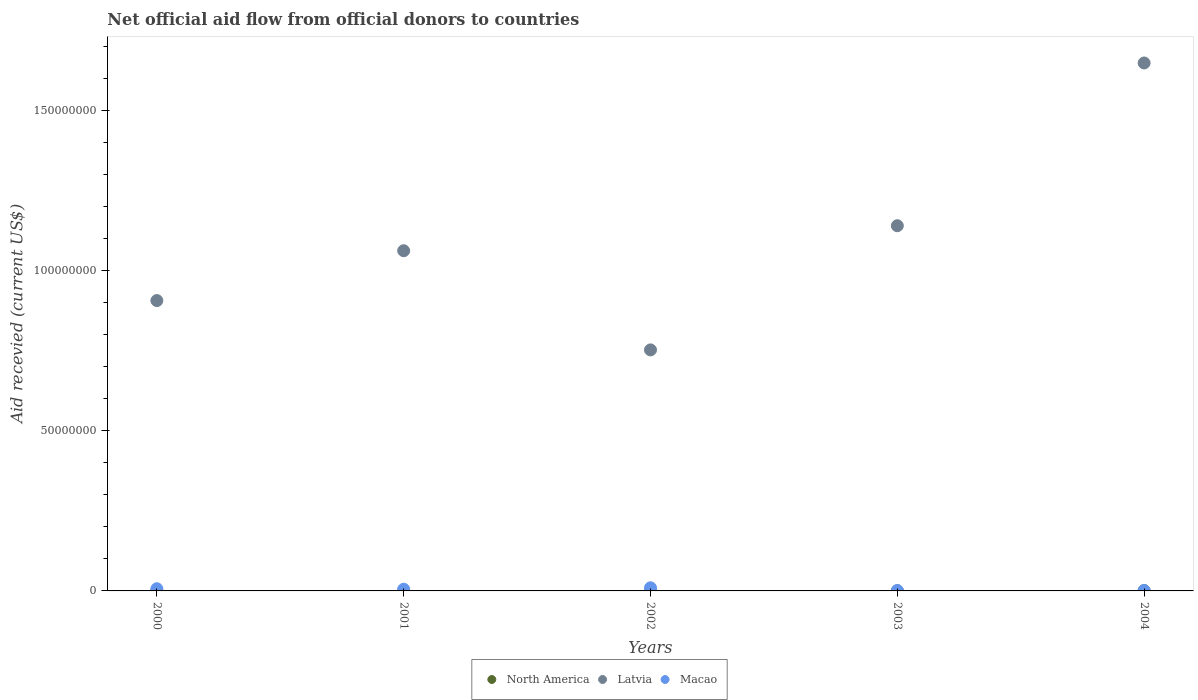How many different coloured dotlines are there?
Make the answer very short. 3. Is the number of dotlines equal to the number of legend labels?
Keep it short and to the point. Yes. Across all years, what is the maximum total aid received in Latvia?
Make the answer very short. 1.65e+08. In which year was the total aid received in North America minimum?
Keep it short and to the point. 2001. What is the total total aid received in Macao in the graph?
Make the answer very short. 2.44e+06. What is the average total aid received in North America per year?
Give a very brief answer. 4.40e+04. In the year 2003, what is the difference between the total aid received in Macao and total aid received in Latvia?
Your answer should be very brief. -1.14e+08. Is the total aid received in North America in 2001 less than that in 2004?
Your answer should be compact. Yes. What is the difference between the highest and the lowest total aid received in Macao?
Offer a very short reply. 8.60e+05. Is the sum of the total aid received in North America in 2000 and 2002 greater than the maximum total aid received in Latvia across all years?
Your response must be concise. No. Is it the case that in every year, the sum of the total aid received in Macao and total aid received in Latvia  is greater than the total aid received in North America?
Provide a short and direct response. Yes. Does the total aid received in Macao monotonically increase over the years?
Keep it short and to the point. No. Is the total aid received in Macao strictly less than the total aid received in North America over the years?
Keep it short and to the point. No. How many years are there in the graph?
Your answer should be compact. 5. What is the difference between two consecutive major ticks on the Y-axis?
Offer a terse response. 5.00e+07. Are the values on the major ticks of Y-axis written in scientific E-notation?
Make the answer very short. No. Does the graph contain any zero values?
Your answer should be compact. No. Does the graph contain grids?
Offer a very short reply. No. How are the legend labels stacked?
Make the answer very short. Horizontal. What is the title of the graph?
Ensure brevity in your answer.  Net official aid flow from official donors to countries. What is the label or title of the X-axis?
Provide a succinct answer. Years. What is the label or title of the Y-axis?
Keep it short and to the point. Aid recevied (current US$). What is the Aid recevied (current US$) of Latvia in 2000?
Ensure brevity in your answer.  9.06e+07. What is the Aid recevied (current US$) of Macao in 2000?
Give a very brief answer. 6.80e+05. What is the Aid recevied (current US$) of Latvia in 2001?
Offer a terse response. 1.06e+08. What is the Aid recevied (current US$) of Macao in 2001?
Provide a succinct answer. 5.30e+05. What is the Aid recevied (current US$) of North America in 2002?
Give a very brief answer. 2.00e+04. What is the Aid recevied (current US$) of Latvia in 2002?
Your answer should be very brief. 7.52e+07. What is the Aid recevied (current US$) of Macao in 2002?
Your answer should be very brief. 9.80e+05. What is the Aid recevied (current US$) in North America in 2003?
Provide a succinct answer. 3.00e+04. What is the Aid recevied (current US$) of Latvia in 2003?
Offer a very short reply. 1.14e+08. What is the Aid recevied (current US$) of Macao in 2003?
Provide a short and direct response. 1.30e+05. What is the Aid recevied (current US$) in Latvia in 2004?
Provide a succinct answer. 1.65e+08. What is the Aid recevied (current US$) in Macao in 2004?
Keep it short and to the point. 1.20e+05. Across all years, what is the maximum Aid recevied (current US$) in Latvia?
Provide a succinct answer. 1.65e+08. Across all years, what is the maximum Aid recevied (current US$) in Macao?
Your response must be concise. 9.80e+05. Across all years, what is the minimum Aid recevied (current US$) of North America?
Your response must be concise. 2.00e+04. Across all years, what is the minimum Aid recevied (current US$) in Latvia?
Your response must be concise. 7.52e+07. Across all years, what is the minimum Aid recevied (current US$) of Macao?
Provide a succinct answer. 1.20e+05. What is the total Aid recevied (current US$) of North America in the graph?
Your answer should be compact. 2.20e+05. What is the total Aid recevied (current US$) in Latvia in the graph?
Your response must be concise. 5.51e+08. What is the total Aid recevied (current US$) of Macao in the graph?
Offer a very short reply. 2.44e+06. What is the difference between the Aid recevied (current US$) of Latvia in 2000 and that in 2001?
Ensure brevity in your answer.  -1.56e+07. What is the difference between the Aid recevied (current US$) in Macao in 2000 and that in 2001?
Give a very brief answer. 1.50e+05. What is the difference between the Aid recevied (current US$) of North America in 2000 and that in 2002?
Ensure brevity in your answer.  4.00e+04. What is the difference between the Aid recevied (current US$) in Latvia in 2000 and that in 2002?
Your response must be concise. 1.54e+07. What is the difference between the Aid recevied (current US$) of Latvia in 2000 and that in 2003?
Provide a succinct answer. -2.34e+07. What is the difference between the Aid recevied (current US$) of Macao in 2000 and that in 2003?
Your answer should be very brief. 5.50e+05. What is the difference between the Aid recevied (current US$) in North America in 2000 and that in 2004?
Provide a succinct answer. -3.00e+04. What is the difference between the Aid recevied (current US$) in Latvia in 2000 and that in 2004?
Provide a succinct answer. -7.41e+07. What is the difference between the Aid recevied (current US$) of Macao in 2000 and that in 2004?
Offer a terse response. 5.60e+05. What is the difference between the Aid recevied (current US$) of North America in 2001 and that in 2002?
Your answer should be compact. 0. What is the difference between the Aid recevied (current US$) in Latvia in 2001 and that in 2002?
Make the answer very short. 3.09e+07. What is the difference between the Aid recevied (current US$) of Macao in 2001 and that in 2002?
Your response must be concise. -4.50e+05. What is the difference between the Aid recevied (current US$) of Latvia in 2001 and that in 2003?
Your answer should be very brief. -7.80e+06. What is the difference between the Aid recevied (current US$) of North America in 2001 and that in 2004?
Offer a very short reply. -7.00e+04. What is the difference between the Aid recevied (current US$) of Latvia in 2001 and that in 2004?
Provide a short and direct response. -5.86e+07. What is the difference between the Aid recevied (current US$) in Macao in 2001 and that in 2004?
Keep it short and to the point. 4.10e+05. What is the difference between the Aid recevied (current US$) of Latvia in 2002 and that in 2003?
Make the answer very short. -3.87e+07. What is the difference between the Aid recevied (current US$) of Macao in 2002 and that in 2003?
Offer a terse response. 8.50e+05. What is the difference between the Aid recevied (current US$) of North America in 2002 and that in 2004?
Provide a succinct answer. -7.00e+04. What is the difference between the Aid recevied (current US$) in Latvia in 2002 and that in 2004?
Provide a short and direct response. -8.95e+07. What is the difference between the Aid recevied (current US$) of Macao in 2002 and that in 2004?
Your answer should be compact. 8.60e+05. What is the difference between the Aid recevied (current US$) in Latvia in 2003 and that in 2004?
Provide a succinct answer. -5.08e+07. What is the difference between the Aid recevied (current US$) in Macao in 2003 and that in 2004?
Your response must be concise. 10000. What is the difference between the Aid recevied (current US$) of North America in 2000 and the Aid recevied (current US$) of Latvia in 2001?
Your answer should be very brief. -1.06e+08. What is the difference between the Aid recevied (current US$) in North America in 2000 and the Aid recevied (current US$) in Macao in 2001?
Provide a succinct answer. -4.70e+05. What is the difference between the Aid recevied (current US$) of Latvia in 2000 and the Aid recevied (current US$) of Macao in 2001?
Offer a very short reply. 9.01e+07. What is the difference between the Aid recevied (current US$) of North America in 2000 and the Aid recevied (current US$) of Latvia in 2002?
Keep it short and to the point. -7.51e+07. What is the difference between the Aid recevied (current US$) of North America in 2000 and the Aid recevied (current US$) of Macao in 2002?
Provide a succinct answer. -9.20e+05. What is the difference between the Aid recevied (current US$) in Latvia in 2000 and the Aid recevied (current US$) in Macao in 2002?
Give a very brief answer. 8.96e+07. What is the difference between the Aid recevied (current US$) in North America in 2000 and the Aid recevied (current US$) in Latvia in 2003?
Give a very brief answer. -1.14e+08. What is the difference between the Aid recevied (current US$) of North America in 2000 and the Aid recevied (current US$) of Macao in 2003?
Your answer should be compact. -7.00e+04. What is the difference between the Aid recevied (current US$) in Latvia in 2000 and the Aid recevied (current US$) in Macao in 2003?
Your response must be concise. 9.05e+07. What is the difference between the Aid recevied (current US$) in North America in 2000 and the Aid recevied (current US$) in Latvia in 2004?
Ensure brevity in your answer.  -1.65e+08. What is the difference between the Aid recevied (current US$) of Latvia in 2000 and the Aid recevied (current US$) of Macao in 2004?
Your response must be concise. 9.05e+07. What is the difference between the Aid recevied (current US$) in North America in 2001 and the Aid recevied (current US$) in Latvia in 2002?
Offer a terse response. -7.52e+07. What is the difference between the Aid recevied (current US$) of North America in 2001 and the Aid recevied (current US$) of Macao in 2002?
Make the answer very short. -9.60e+05. What is the difference between the Aid recevied (current US$) of Latvia in 2001 and the Aid recevied (current US$) of Macao in 2002?
Give a very brief answer. 1.05e+08. What is the difference between the Aid recevied (current US$) of North America in 2001 and the Aid recevied (current US$) of Latvia in 2003?
Give a very brief answer. -1.14e+08. What is the difference between the Aid recevied (current US$) in North America in 2001 and the Aid recevied (current US$) in Macao in 2003?
Your answer should be very brief. -1.10e+05. What is the difference between the Aid recevied (current US$) of Latvia in 2001 and the Aid recevied (current US$) of Macao in 2003?
Provide a succinct answer. 1.06e+08. What is the difference between the Aid recevied (current US$) of North America in 2001 and the Aid recevied (current US$) of Latvia in 2004?
Your response must be concise. -1.65e+08. What is the difference between the Aid recevied (current US$) in North America in 2001 and the Aid recevied (current US$) in Macao in 2004?
Provide a short and direct response. -1.00e+05. What is the difference between the Aid recevied (current US$) of Latvia in 2001 and the Aid recevied (current US$) of Macao in 2004?
Your response must be concise. 1.06e+08. What is the difference between the Aid recevied (current US$) in North America in 2002 and the Aid recevied (current US$) in Latvia in 2003?
Offer a terse response. -1.14e+08. What is the difference between the Aid recevied (current US$) of Latvia in 2002 and the Aid recevied (current US$) of Macao in 2003?
Provide a short and direct response. 7.51e+07. What is the difference between the Aid recevied (current US$) of North America in 2002 and the Aid recevied (current US$) of Latvia in 2004?
Make the answer very short. -1.65e+08. What is the difference between the Aid recevied (current US$) of North America in 2002 and the Aid recevied (current US$) of Macao in 2004?
Ensure brevity in your answer.  -1.00e+05. What is the difference between the Aid recevied (current US$) of Latvia in 2002 and the Aid recevied (current US$) of Macao in 2004?
Make the answer very short. 7.51e+07. What is the difference between the Aid recevied (current US$) in North America in 2003 and the Aid recevied (current US$) in Latvia in 2004?
Make the answer very short. -1.65e+08. What is the difference between the Aid recevied (current US$) in Latvia in 2003 and the Aid recevied (current US$) in Macao in 2004?
Give a very brief answer. 1.14e+08. What is the average Aid recevied (current US$) of North America per year?
Your answer should be very brief. 4.40e+04. What is the average Aid recevied (current US$) of Latvia per year?
Give a very brief answer. 1.10e+08. What is the average Aid recevied (current US$) of Macao per year?
Offer a very short reply. 4.88e+05. In the year 2000, what is the difference between the Aid recevied (current US$) of North America and Aid recevied (current US$) of Latvia?
Make the answer very short. -9.05e+07. In the year 2000, what is the difference between the Aid recevied (current US$) of North America and Aid recevied (current US$) of Macao?
Offer a very short reply. -6.20e+05. In the year 2000, what is the difference between the Aid recevied (current US$) of Latvia and Aid recevied (current US$) of Macao?
Provide a succinct answer. 8.99e+07. In the year 2001, what is the difference between the Aid recevied (current US$) in North America and Aid recevied (current US$) in Latvia?
Your answer should be compact. -1.06e+08. In the year 2001, what is the difference between the Aid recevied (current US$) in North America and Aid recevied (current US$) in Macao?
Offer a very short reply. -5.10e+05. In the year 2001, what is the difference between the Aid recevied (current US$) in Latvia and Aid recevied (current US$) in Macao?
Keep it short and to the point. 1.06e+08. In the year 2002, what is the difference between the Aid recevied (current US$) of North America and Aid recevied (current US$) of Latvia?
Provide a short and direct response. -7.52e+07. In the year 2002, what is the difference between the Aid recevied (current US$) in North America and Aid recevied (current US$) in Macao?
Your answer should be compact. -9.60e+05. In the year 2002, what is the difference between the Aid recevied (current US$) of Latvia and Aid recevied (current US$) of Macao?
Give a very brief answer. 7.42e+07. In the year 2003, what is the difference between the Aid recevied (current US$) of North America and Aid recevied (current US$) of Latvia?
Provide a succinct answer. -1.14e+08. In the year 2003, what is the difference between the Aid recevied (current US$) in Latvia and Aid recevied (current US$) in Macao?
Keep it short and to the point. 1.14e+08. In the year 2004, what is the difference between the Aid recevied (current US$) of North America and Aid recevied (current US$) of Latvia?
Provide a short and direct response. -1.65e+08. In the year 2004, what is the difference between the Aid recevied (current US$) of Latvia and Aid recevied (current US$) of Macao?
Your answer should be very brief. 1.65e+08. What is the ratio of the Aid recevied (current US$) in North America in 2000 to that in 2001?
Your answer should be very brief. 3. What is the ratio of the Aid recevied (current US$) of Latvia in 2000 to that in 2001?
Provide a short and direct response. 0.85. What is the ratio of the Aid recevied (current US$) in Macao in 2000 to that in 2001?
Make the answer very short. 1.28. What is the ratio of the Aid recevied (current US$) of Latvia in 2000 to that in 2002?
Keep it short and to the point. 1.2. What is the ratio of the Aid recevied (current US$) of Macao in 2000 to that in 2002?
Make the answer very short. 0.69. What is the ratio of the Aid recevied (current US$) in North America in 2000 to that in 2003?
Your answer should be very brief. 2. What is the ratio of the Aid recevied (current US$) in Latvia in 2000 to that in 2003?
Keep it short and to the point. 0.8. What is the ratio of the Aid recevied (current US$) of Macao in 2000 to that in 2003?
Your answer should be compact. 5.23. What is the ratio of the Aid recevied (current US$) of North America in 2000 to that in 2004?
Offer a terse response. 0.67. What is the ratio of the Aid recevied (current US$) in Latvia in 2000 to that in 2004?
Provide a short and direct response. 0.55. What is the ratio of the Aid recevied (current US$) of Macao in 2000 to that in 2004?
Make the answer very short. 5.67. What is the ratio of the Aid recevied (current US$) in Latvia in 2001 to that in 2002?
Keep it short and to the point. 1.41. What is the ratio of the Aid recevied (current US$) in Macao in 2001 to that in 2002?
Your answer should be very brief. 0.54. What is the ratio of the Aid recevied (current US$) of Latvia in 2001 to that in 2003?
Provide a succinct answer. 0.93. What is the ratio of the Aid recevied (current US$) of Macao in 2001 to that in 2003?
Offer a very short reply. 4.08. What is the ratio of the Aid recevied (current US$) of North America in 2001 to that in 2004?
Your answer should be very brief. 0.22. What is the ratio of the Aid recevied (current US$) of Latvia in 2001 to that in 2004?
Your answer should be compact. 0.64. What is the ratio of the Aid recevied (current US$) in Macao in 2001 to that in 2004?
Ensure brevity in your answer.  4.42. What is the ratio of the Aid recevied (current US$) of North America in 2002 to that in 2003?
Offer a terse response. 0.67. What is the ratio of the Aid recevied (current US$) of Latvia in 2002 to that in 2003?
Ensure brevity in your answer.  0.66. What is the ratio of the Aid recevied (current US$) of Macao in 2002 to that in 2003?
Keep it short and to the point. 7.54. What is the ratio of the Aid recevied (current US$) in North America in 2002 to that in 2004?
Your answer should be very brief. 0.22. What is the ratio of the Aid recevied (current US$) of Latvia in 2002 to that in 2004?
Offer a very short reply. 0.46. What is the ratio of the Aid recevied (current US$) in Macao in 2002 to that in 2004?
Provide a short and direct response. 8.17. What is the ratio of the Aid recevied (current US$) of Latvia in 2003 to that in 2004?
Offer a very short reply. 0.69. What is the ratio of the Aid recevied (current US$) in Macao in 2003 to that in 2004?
Keep it short and to the point. 1.08. What is the difference between the highest and the second highest Aid recevied (current US$) of Latvia?
Your response must be concise. 5.08e+07. What is the difference between the highest and the second highest Aid recevied (current US$) of Macao?
Provide a succinct answer. 3.00e+05. What is the difference between the highest and the lowest Aid recevied (current US$) in North America?
Your response must be concise. 7.00e+04. What is the difference between the highest and the lowest Aid recevied (current US$) in Latvia?
Make the answer very short. 8.95e+07. What is the difference between the highest and the lowest Aid recevied (current US$) in Macao?
Provide a short and direct response. 8.60e+05. 